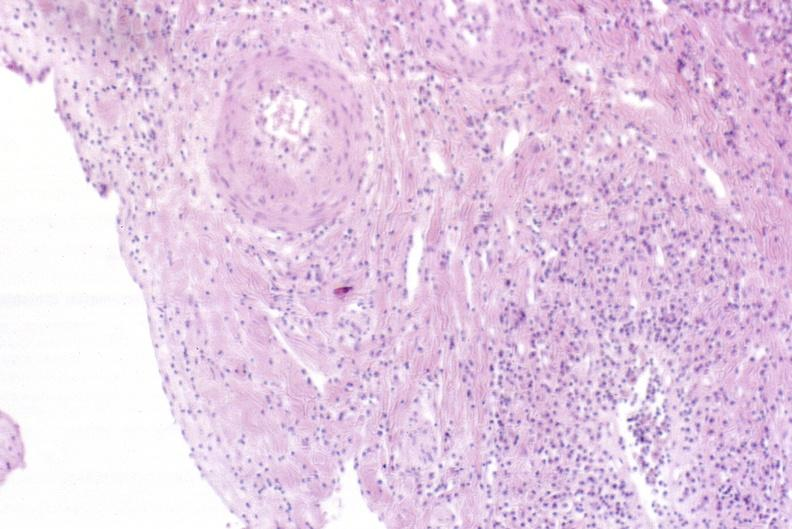what is present?
Answer the question using a single word or phrase. Hepatobiliary 